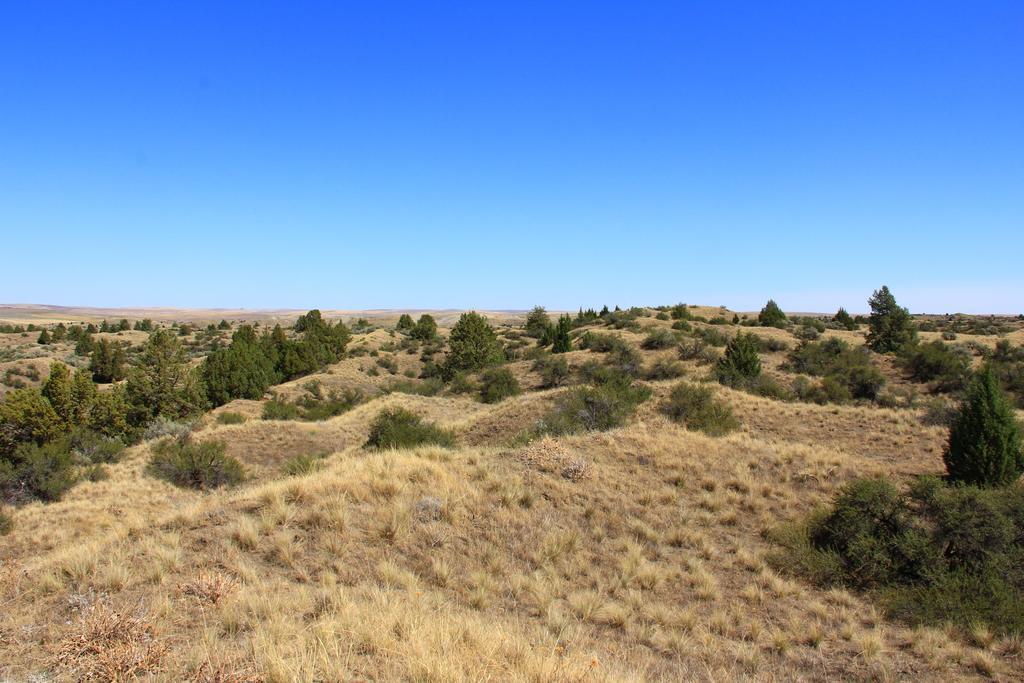Could you give a brief overview of what you see in this image? In the picture I can see the grass, plants and trees. In the background I can see the sky. 